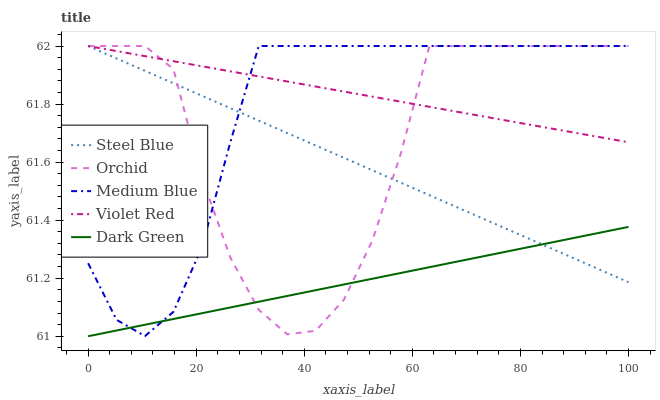Does Dark Green have the minimum area under the curve?
Answer yes or no. Yes. Does Violet Red have the maximum area under the curve?
Answer yes or no. Yes. Does Medium Blue have the minimum area under the curve?
Answer yes or no. No. Does Medium Blue have the maximum area under the curve?
Answer yes or no. No. Is Dark Green the smoothest?
Answer yes or no. Yes. Is Orchid the roughest?
Answer yes or no. Yes. Is Medium Blue the smoothest?
Answer yes or no. No. Is Medium Blue the roughest?
Answer yes or no. No. Does Dark Green have the lowest value?
Answer yes or no. Yes. Does Medium Blue have the lowest value?
Answer yes or no. No. Does Orchid have the highest value?
Answer yes or no. Yes. Does Dark Green have the highest value?
Answer yes or no. No. Is Dark Green less than Violet Red?
Answer yes or no. Yes. Is Violet Red greater than Dark Green?
Answer yes or no. Yes. Does Violet Red intersect Medium Blue?
Answer yes or no. Yes. Is Violet Red less than Medium Blue?
Answer yes or no. No. Is Violet Red greater than Medium Blue?
Answer yes or no. No. Does Dark Green intersect Violet Red?
Answer yes or no. No. 